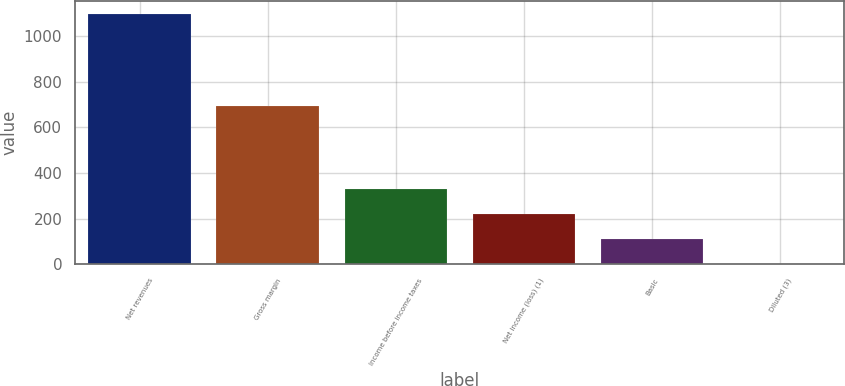Convert chart. <chart><loc_0><loc_0><loc_500><loc_500><bar_chart><fcel>Net revenues<fcel>Gross margin<fcel>Income before income taxes<fcel>Net income (loss) (1)<fcel>Basic<fcel>Diluted (3)<nl><fcel>1097.9<fcel>690.9<fcel>329.54<fcel>219.77<fcel>110<fcel>0.23<nl></chart> 